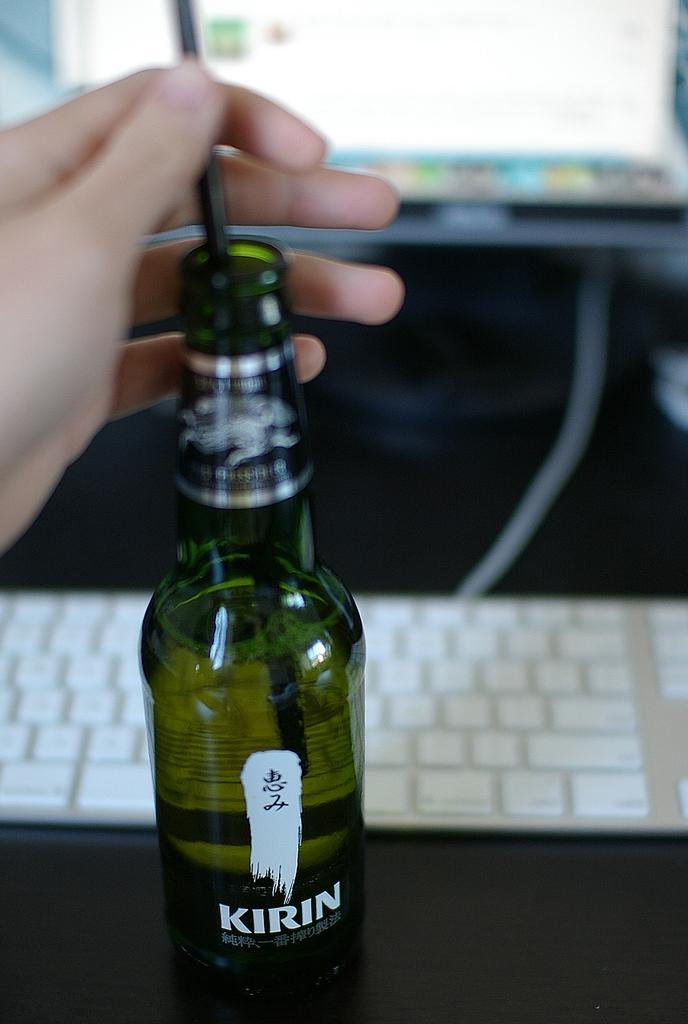<image>
Present a compact description of the photo's key features. A person drinking from a foreign beer Kirin brand in front of a computer. 